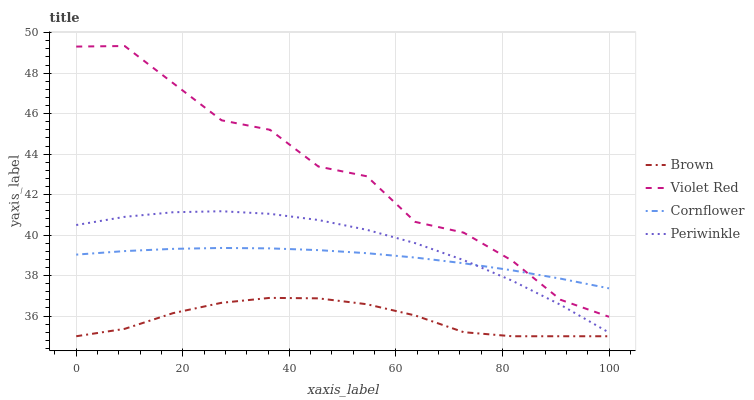Does Brown have the minimum area under the curve?
Answer yes or no. Yes. Does Violet Red have the maximum area under the curve?
Answer yes or no. Yes. Does Periwinkle have the minimum area under the curve?
Answer yes or no. No. Does Periwinkle have the maximum area under the curve?
Answer yes or no. No. Is Cornflower the smoothest?
Answer yes or no. Yes. Is Violet Red the roughest?
Answer yes or no. Yes. Is Periwinkle the smoothest?
Answer yes or no. No. Is Periwinkle the roughest?
Answer yes or no. No. Does Brown have the lowest value?
Answer yes or no. Yes. Does Violet Red have the lowest value?
Answer yes or no. No. Does Violet Red have the highest value?
Answer yes or no. Yes. Does Periwinkle have the highest value?
Answer yes or no. No. Is Periwinkle less than Violet Red?
Answer yes or no. Yes. Is Violet Red greater than Periwinkle?
Answer yes or no. Yes. Does Periwinkle intersect Cornflower?
Answer yes or no. Yes. Is Periwinkle less than Cornflower?
Answer yes or no. No. Is Periwinkle greater than Cornflower?
Answer yes or no. No. Does Periwinkle intersect Violet Red?
Answer yes or no. No. 